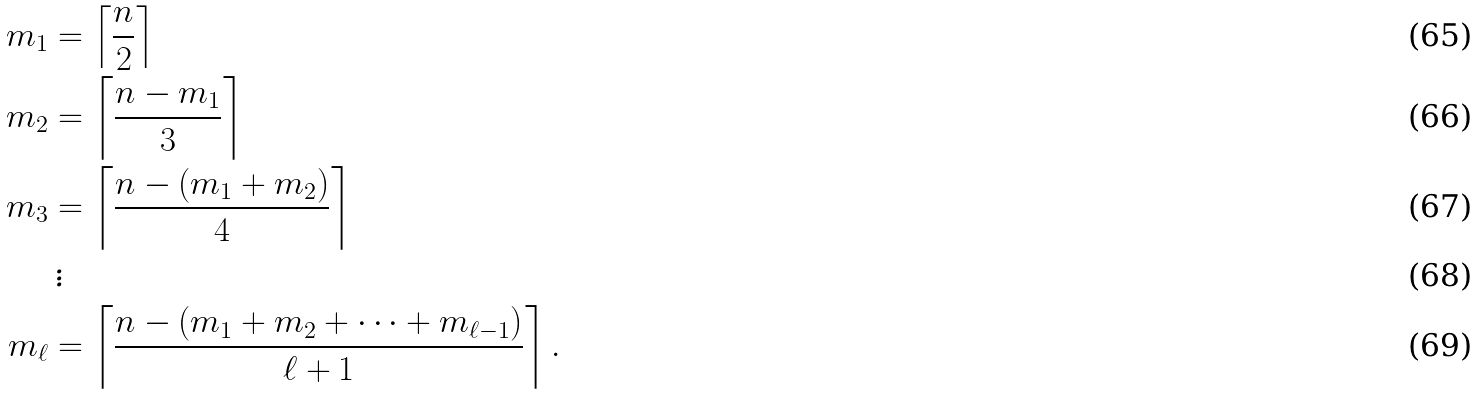Convert formula to latex. <formula><loc_0><loc_0><loc_500><loc_500>m _ { 1 } & = \left \lceil \frac { n } { 2 } \right \rceil \\ m _ { 2 } & = \left \lceil \frac { n - m _ { 1 } } { 3 } \right \rceil \\ m _ { 3 } & = \left \lceil \frac { n - ( m _ { 1 } + m _ { 2 } ) } { 4 } \right \rceil \\ & \, \vdots \\ m _ { \ell } & = \left \lceil \frac { n - ( m _ { 1 } + m _ { 2 } + \cdots + m _ { \ell - 1 } ) } { \ell + 1 } \right \rceil .</formula> 